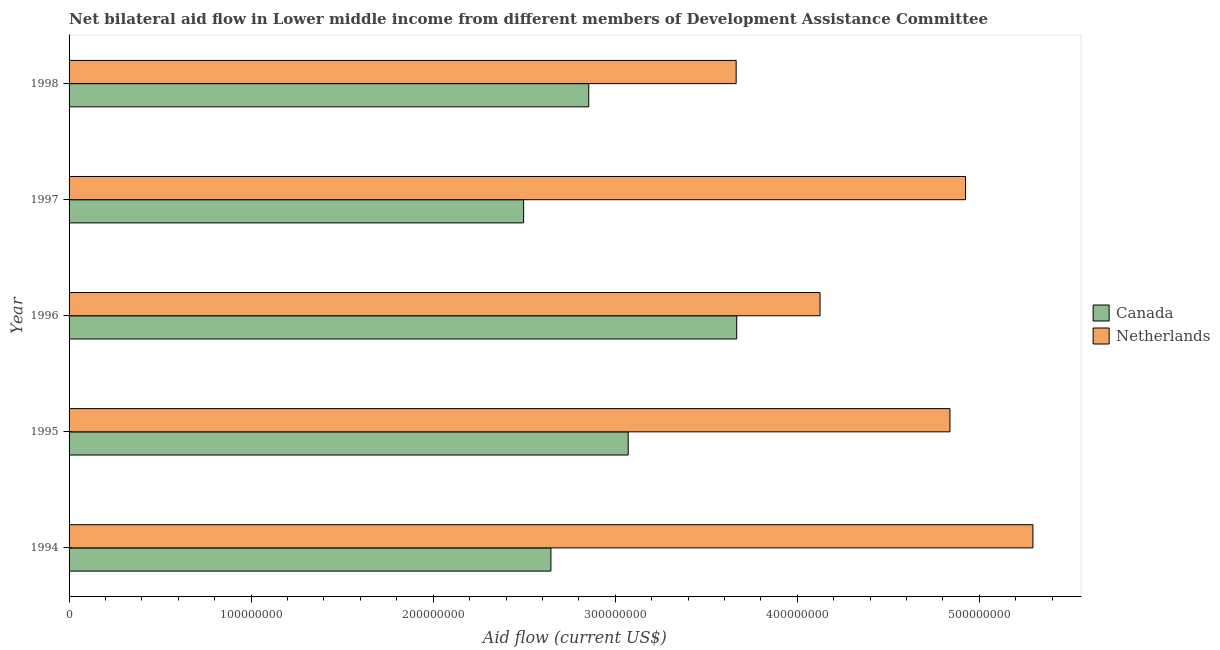How many different coloured bars are there?
Your response must be concise. 2. Are the number of bars per tick equal to the number of legend labels?
Your response must be concise. Yes. Are the number of bars on each tick of the Y-axis equal?
Your answer should be very brief. Yes. What is the label of the 1st group of bars from the top?
Provide a succinct answer. 1998. In how many cases, is the number of bars for a given year not equal to the number of legend labels?
Offer a terse response. 0. What is the amount of aid given by netherlands in 1996?
Give a very brief answer. 4.12e+08. Across all years, what is the maximum amount of aid given by canada?
Make the answer very short. 3.67e+08. Across all years, what is the minimum amount of aid given by canada?
Provide a short and direct response. 2.50e+08. In which year was the amount of aid given by netherlands minimum?
Offer a terse response. 1998. What is the total amount of aid given by netherlands in the graph?
Your answer should be compact. 2.28e+09. What is the difference between the amount of aid given by canada in 1994 and that in 1998?
Provide a succinct answer. -2.08e+07. What is the difference between the amount of aid given by canada in 1998 and the amount of aid given by netherlands in 1994?
Provide a succinct answer. -2.44e+08. What is the average amount of aid given by netherlands per year?
Give a very brief answer. 4.57e+08. In the year 1997, what is the difference between the amount of aid given by netherlands and amount of aid given by canada?
Offer a very short reply. 2.43e+08. In how many years, is the amount of aid given by netherlands greater than 420000000 US$?
Keep it short and to the point. 3. What is the ratio of the amount of aid given by netherlands in 1996 to that in 1997?
Offer a terse response. 0.84. Is the difference between the amount of aid given by canada in 1997 and 1998 greater than the difference between the amount of aid given by netherlands in 1997 and 1998?
Offer a very short reply. No. What is the difference between the highest and the second highest amount of aid given by netherlands?
Provide a succinct answer. 3.70e+07. What is the difference between the highest and the lowest amount of aid given by netherlands?
Provide a succinct answer. 1.63e+08. Is the sum of the amount of aid given by canada in 1996 and 1997 greater than the maximum amount of aid given by netherlands across all years?
Keep it short and to the point. Yes. What does the 2nd bar from the top in 1998 represents?
Provide a succinct answer. Canada. What does the 2nd bar from the bottom in 1998 represents?
Provide a short and direct response. Netherlands. How many bars are there?
Provide a short and direct response. 10. How many years are there in the graph?
Offer a very short reply. 5. What is the difference between two consecutive major ticks on the X-axis?
Provide a succinct answer. 1.00e+08. Are the values on the major ticks of X-axis written in scientific E-notation?
Offer a terse response. No. Where does the legend appear in the graph?
Your answer should be compact. Center right. How are the legend labels stacked?
Your response must be concise. Vertical. What is the title of the graph?
Your response must be concise. Net bilateral aid flow in Lower middle income from different members of Development Assistance Committee. What is the label or title of the Y-axis?
Provide a succinct answer. Year. What is the Aid flow (current US$) in Canada in 1994?
Make the answer very short. 2.65e+08. What is the Aid flow (current US$) in Netherlands in 1994?
Offer a very short reply. 5.29e+08. What is the Aid flow (current US$) of Canada in 1995?
Your answer should be compact. 3.07e+08. What is the Aid flow (current US$) in Netherlands in 1995?
Make the answer very short. 4.84e+08. What is the Aid flow (current US$) of Canada in 1996?
Offer a terse response. 3.67e+08. What is the Aid flow (current US$) in Netherlands in 1996?
Make the answer very short. 4.12e+08. What is the Aid flow (current US$) of Canada in 1997?
Provide a short and direct response. 2.50e+08. What is the Aid flow (current US$) of Netherlands in 1997?
Your answer should be very brief. 4.92e+08. What is the Aid flow (current US$) of Canada in 1998?
Give a very brief answer. 2.85e+08. What is the Aid flow (current US$) in Netherlands in 1998?
Your answer should be compact. 3.66e+08. Across all years, what is the maximum Aid flow (current US$) in Canada?
Offer a very short reply. 3.67e+08. Across all years, what is the maximum Aid flow (current US$) of Netherlands?
Give a very brief answer. 5.29e+08. Across all years, what is the minimum Aid flow (current US$) in Canada?
Provide a succinct answer. 2.50e+08. Across all years, what is the minimum Aid flow (current US$) of Netherlands?
Your answer should be compact. 3.66e+08. What is the total Aid flow (current US$) of Canada in the graph?
Keep it short and to the point. 1.47e+09. What is the total Aid flow (current US$) of Netherlands in the graph?
Make the answer very short. 2.28e+09. What is the difference between the Aid flow (current US$) in Canada in 1994 and that in 1995?
Ensure brevity in your answer.  -4.24e+07. What is the difference between the Aid flow (current US$) of Netherlands in 1994 and that in 1995?
Your answer should be compact. 4.56e+07. What is the difference between the Aid flow (current US$) in Canada in 1994 and that in 1996?
Make the answer very short. -1.02e+08. What is the difference between the Aid flow (current US$) in Netherlands in 1994 and that in 1996?
Your answer should be very brief. 1.17e+08. What is the difference between the Aid flow (current US$) in Canada in 1994 and that in 1997?
Ensure brevity in your answer.  1.50e+07. What is the difference between the Aid flow (current US$) of Netherlands in 1994 and that in 1997?
Offer a terse response. 3.70e+07. What is the difference between the Aid flow (current US$) of Canada in 1994 and that in 1998?
Give a very brief answer. -2.08e+07. What is the difference between the Aid flow (current US$) of Netherlands in 1994 and that in 1998?
Offer a terse response. 1.63e+08. What is the difference between the Aid flow (current US$) in Canada in 1995 and that in 1996?
Make the answer very short. -5.96e+07. What is the difference between the Aid flow (current US$) in Netherlands in 1995 and that in 1996?
Give a very brief answer. 7.14e+07. What is the difference between the Aid flow (current US$) in Canada in 1995 and that in 1997?
Your answer should be compact. 5.74e+07. What is the difference between the Aid flow (current US$) in Netherlands in 1995 and that in 1997?
Provide a short and direct response. -8.56e+06. What is the difference between the Aid flow (current US$) in Canada in 1995 and that in 1998?
Ensure brevity in your answer.  2.17e+07. What is the difference between the Aid flow (current US$) of Netherlands in 1995 and that in 1998?
Offer a terse response. 1.17e+08. What is the difference between the Aid flow (current US$) of Canada in 1996 and that in 1997?
Your response must be concise. 1.17e+08. What is the difference between the Aid flow (current US$) in Netherlands in 1996 and that in 1997?
Offer a terse response. -7.99e+07. What is the difference between the Aid flow (current US$) in Canada in 1996 and that in 1998?
Provide a short and direct response. 8.13e+07. What is the difference between the Aid flow (current US$) in Netherlands in 1996 and that in 1998?
Provide a succinct answer. 4.61e+07. What is the difference between the Aid flow (current US$) in Canada in 1997 and that in 1998?
Your response must be concise. -3.58e+07. What is the difference between the Aid flow (current US$) of Netherlands in 1997 and that in 1998?
Your response must be concise. 1.26e+08. What is the difference between the Aid flow (current US$) in Canada in 1994 and the Aid flow (current US$) in Netherlands in 1995?
Make the answer very short. -2.19e+08. What is the difference between the Aid flow (current US$) in Canada in 1994 and the Aid flow (current US$) in Netherlands in 1996?
Your answer should be very brief. -1.48e+08. What is the difference between the Aid flow (current US$) of Canada in 1994 and the Aid flow (current US$) of Netherlands in 1997?
Make the answer very short. -2.28e+08. What is the difference between the Aid flow (current US$) of Canada in 1994 and the Aid flow (current US$) of Netherlands in 1998?
Provide a succinct answer. -1.02e+08. What is the difference between the Aid flow (current US$) of Canada in 1995 and the Aid flow (current US$) of Netherlands in 1996?
Ensure brevity in your answer.  -1.05e+08. What is the difference between the Aid flow (current US$) of Canada in 1995 and the Aid flow (current US$) of Netherlands in 1997?
Provide a succinct answer. -1.85e+08. What is the difference between the Aid flow (current US$) in Canada in 1995 and the Aid flow (current US$) in Netherlands in 1998?
Offer a terse response. -5.93e+07. What is the difference between the Aid flow (current US$) in Canada in 1996 and the Aid flow (current US$) in Netherlands in 1997?
Ensure brevity in your answer.  -1.26e+08. What is the difference between the Aid flow (current US$) in Canada in 1997 and the Aid flow (current US$) in Netherlands in 1998?
Make the answer very short. -1.17e+08. What is the average Aid flow (current US$) in Canada per year?
Provide a short and direct response. 2.95e+08. What is the average Aid flow (current US$) of Netherlands per year?
Your response must be concise. 4.57e+08. In the year 1994, what is the difference between the Aid flow (current US$) in Canada and Aid flow (current US$) in Netherlands?
Your response must be concise. -2.65e+08. In the year 1995, what is the difference between the Aid flow (current US$) in Canada and Aid flow (current US$) in Netherlands?
Provide a succinct answer. -1.77e+08. In the year 1996, what is the difference between the Aid flow (current US$) in Canada and Aid flow (current US$) in Netherlands?
Ensure brevity in your answer.  -4.58e+07. In the year 1997, what is the difference between the Aid flow (current US$) in Canada and Aid flow (current US$) in Netherlands?
Your answer should be very brief. -2.43e+08. In the year 1998, what is the difference between the Aid flow (current US$) in Canada and Aid flow (current US$) in Netherlands?
Ensure brevity in your answer.  -8.10e+07. What is the ratio of the Aid flow (current US$) of Canada in 1994 to that in 1995?
Give a very brief answer. 0.86. What is the ratio of the Aid flow (current US$) in Netherlands in 1994 to that in 1995?
Your response must be concise. 1.09. What is the ratio of the Aid flow (current US$) in Canada in 1994 to that in 1996?
Keep it short and to the point. 0.72. What is the ratio of the Aid flow (current US$) of Netherlands in 1994 to that in 1996?
Provide a succinct answer. 1.28. What is the ratio of the Aid flow (current US$) in Canada in 1994 to that in 1997?
Provide a short and direct response. 1.06. What is the ratio of the Aid flow (current US$) of Netherlands in 1994 to that in 1997?
Ensure brevity in your answer.  1.08. What is the ratio of the Aid flow (current US$) of Canada in 1994 to that in 1998?
Your answer should be very brief. 0.93. What is the ratio of the Aid flow (current US$) in Netherlands in 1994 to that in 1998?
Your answer should be very brief. 1.44. What is the ratio of the Aid flow (current US$) in Canada in 1995 to that in 1996?
Keep it short and to the point. 0.84. What is the ratio of the Aid flow (current US$) of Netherlands in 1995 to that in 1996?
Give a very brief answer. 1.17. What is the ratio of the Aid flow (current US$) of Canada in 1995 to that in 1997?
Provide a succinct answer. 1.23. What is the ratio of the Aid flow (current US$) in Netherlands in 1995 to that in 1997?
Provide a short and direct response. 0.98. What is the ratio of the Aid flow (current US$) in Canada in 1995 to that in 1998?
Your answer should be very brief. 1.08. What is the ratio of the Aid flow (current US$) in Netherlands in 1995 to that in 1998?
Ensure brevity in your answer.  1.32. What is the ratio of the Aid flow (current US$) in Canada in 1996 to that in 1997?
Make the answer very short. 1.47. What is the ratio of the Aid flow (current US$) of Netherlands in 1996 to that in 1997?
Ensure brevity in your answer.  0.84. What is the ratio of the Aid flow (current US$) of Canada in 1996 to that in 1998?
Your response must be concise. 1.28. What is the ratio of the Aid flow (current US$) of Netherlands in 1996 to that in 1998?
Your response must be concise. 1.13. What is the ratio of the Aid flow (current US$) of Canada in 1997 to that in 1998?
Ensure brevity in your answer.  0.87. What is the ratio of the Aid flow (current US$) of Netherlands in 1997 to that in 1998?
Provide a short and direct response. 1.34. What is the difference between the highest and the second highest Aid flow (current US$) in Canada?
Keep it short and to the point. 5.96e+07. What is the difference between the highest and the second highest Aid flow (current US$) of Netherlands?
Ensure brevity in your answer.  3.70e+07. What is the difference between the highest and the lowest Aid flow (current US$) in Canada?
Your response must be concise. 1.17e+08. What is the difference between the highest and the lowest Aid flow (current US$) in Netherlands?
Your answer should be very brief. 1.63e+08. 